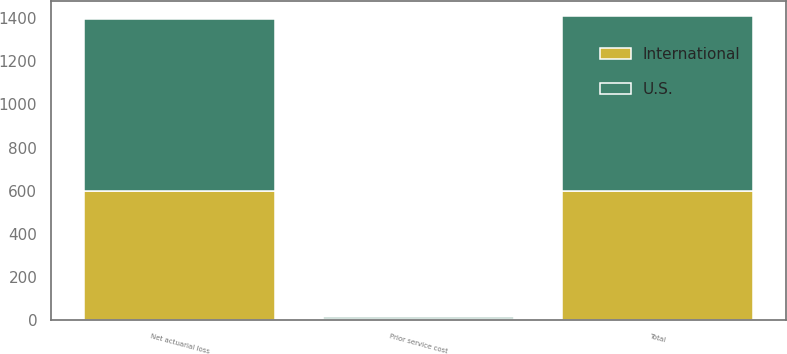<chart> <loc_0><loc_0><loc_500><loc_500><stacked_bar_chart><ecel><fcel>Net actuarial loss<fcel>Prior service cost<fcel>Total<nl><fcel>U.S.<fcel>798.2<fcel>11.7<fcel>809.9<nl><fcel>International<fcel>597.9<fcel>1.1<fcel>599.4<nl></chart> 